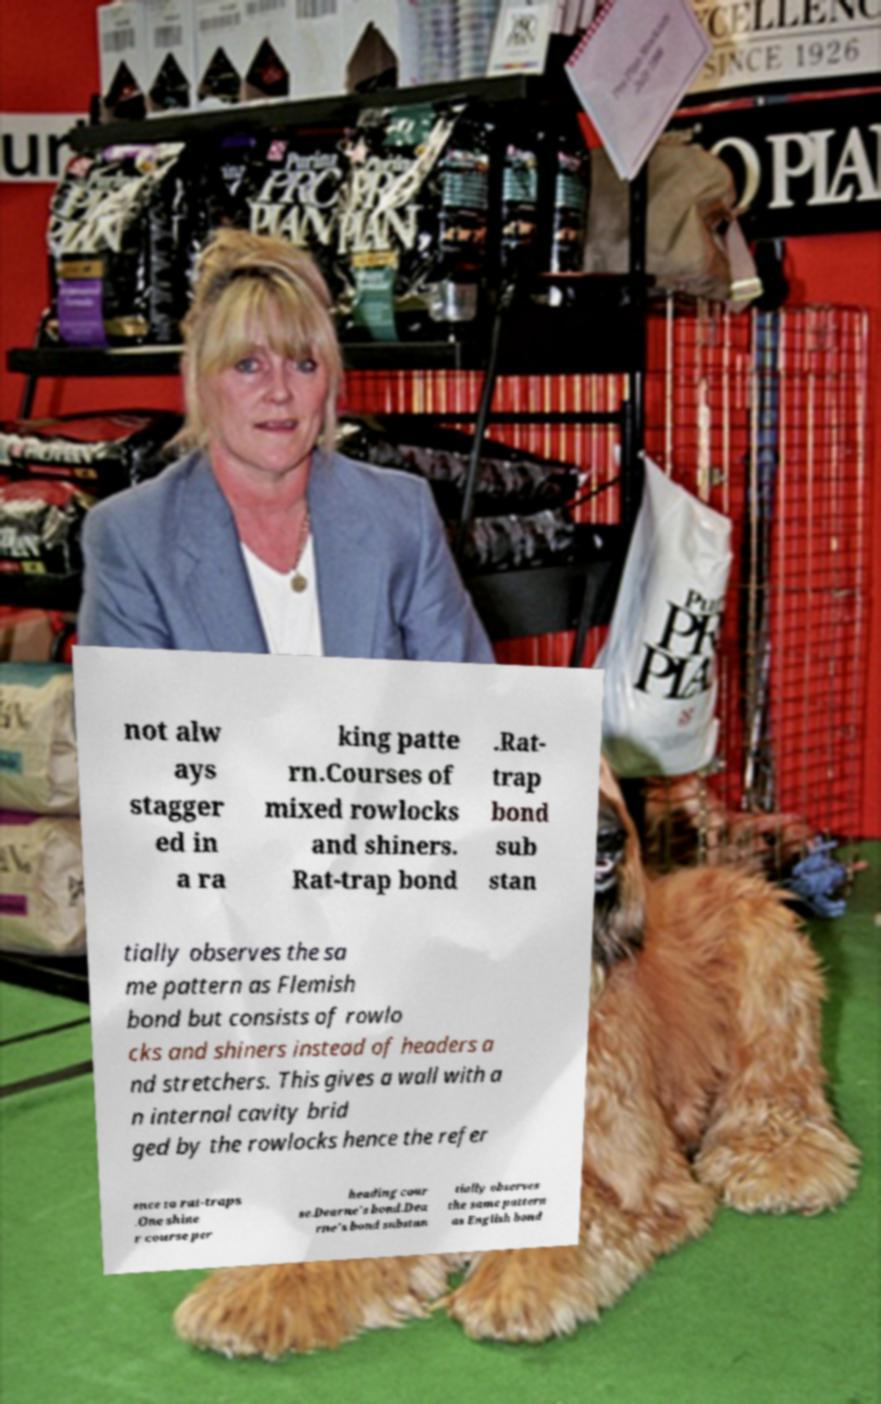I need the written content from this picture converted into text. Can you do that? not alw ays stagger ed in a ra king patte rn.Courses of mixed rowlocks and shiners. Rat-trap bond .Rat- trap bond sub stan tially observes the sa me pattern as Flemish bond but consists of rowlo cks and shiners instead of headers a nd stretchers. This gives a wall with a n internal cavity brid ged by the rowlocks hence the refer ence to rat-traps .One shine r course per heading cour se.Dearne's bond.Dea rne's bond substan tially observes the same pattern as English bond 